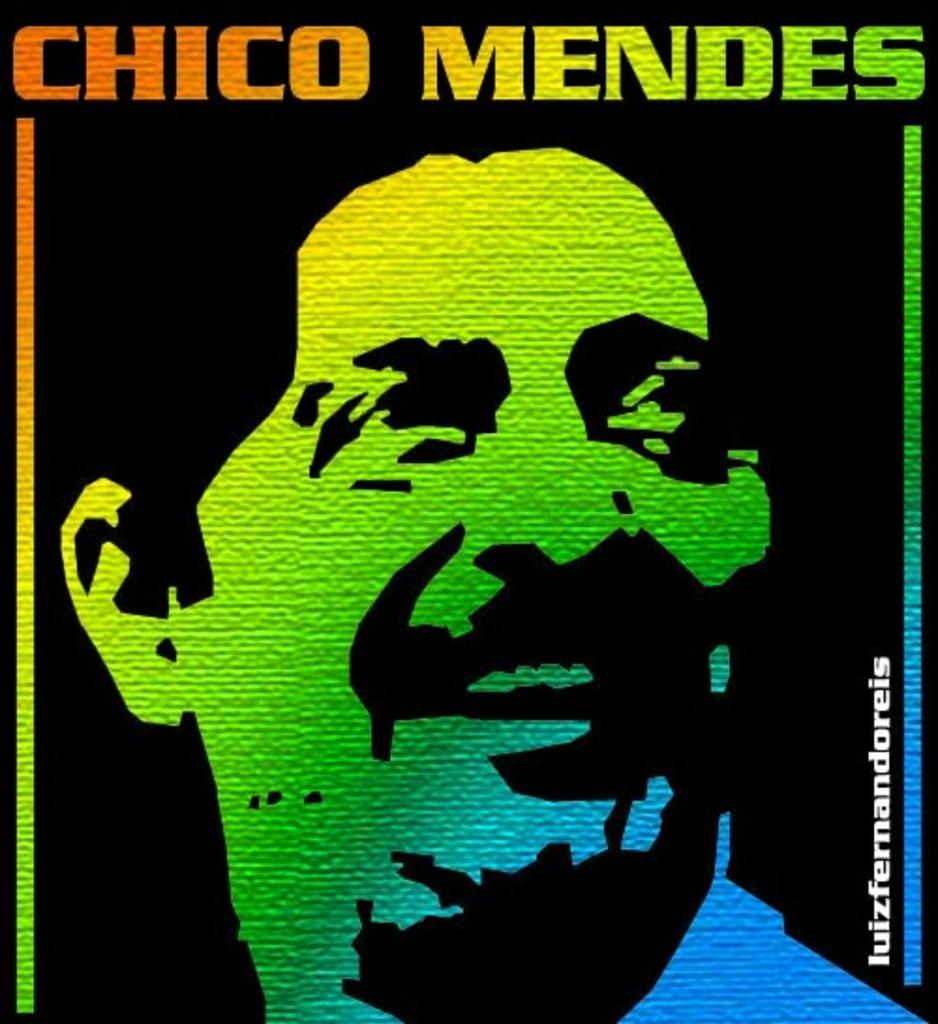What is the name of the album?
Provide a succinct answer. Chico mendes. Whos name is printed on the top of the image?
Provide a short and direct response. Chico mendes. 